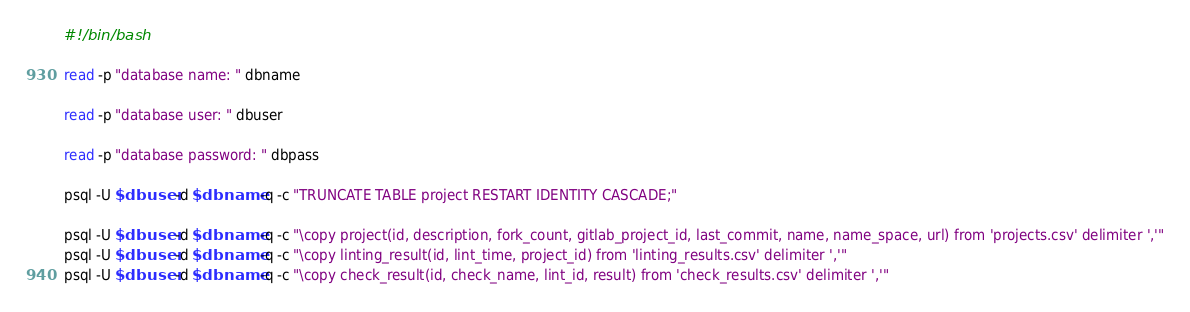Convert code to text. <code><loc_0><loc_0><loc_500><loc_500><_Bash_>#!/bin/bash

read -p "database name: " dbname

read -p "database user: " dbuser

read -p "database password: " dbpass

psql -U $dbuser -d $dbname -q -c "TRUNCATE TABLE project RESTART IDENTITY CASCADE;"

psql -U $dbuser -d $dbname -q -c "\copy project(id, description, fork_count, gitlab_project_id, last_commit, name, name_space, url) from 'projects.csv' delimiter ','"
psql -U $dbuser -d $dbname -q -c "\copy linting_result(id, lint_time, project_id) from 'linting_results.csv' delimiter ','"
psql -U $dbuser -d $dbname -q -c "\copy check_result(id, check_name, lint_id, result) from 'check_results.csv' delimiter ','"
</code> 